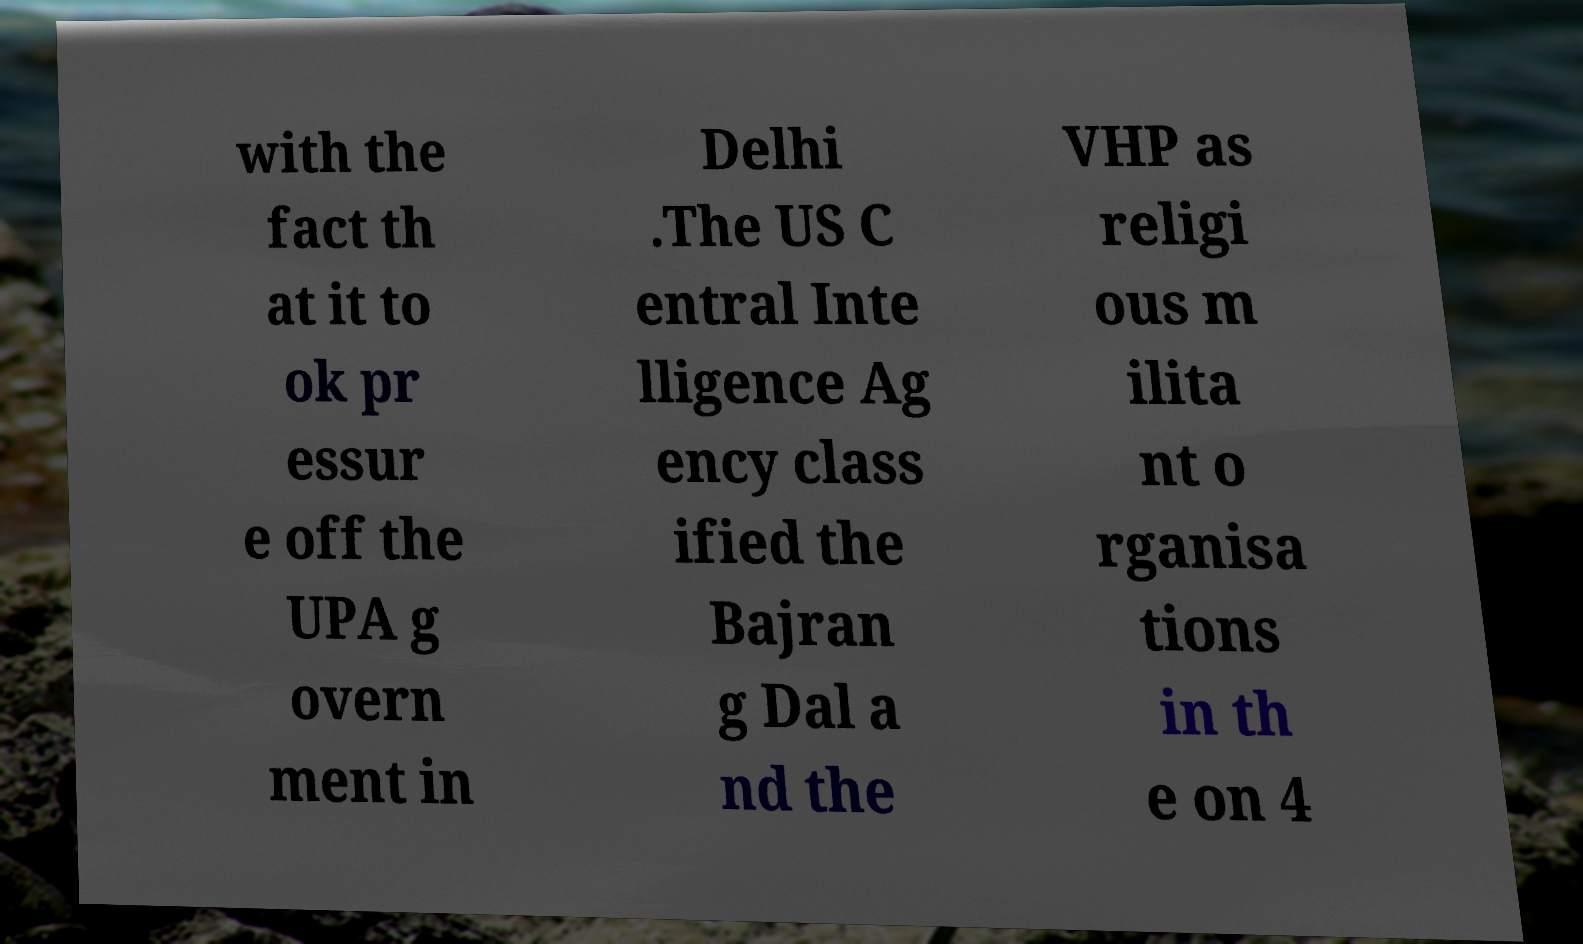Please read and relay the text visible in this image. What does it say? with the fact th at it to ok pr essur e off the UPA g overn ment in Delhi .The US C entral Inte lligence Ag ency class ified the Bajran g Dal a nd the VHP as religi ous m ilita nt o rganisa tions in th e on 4 